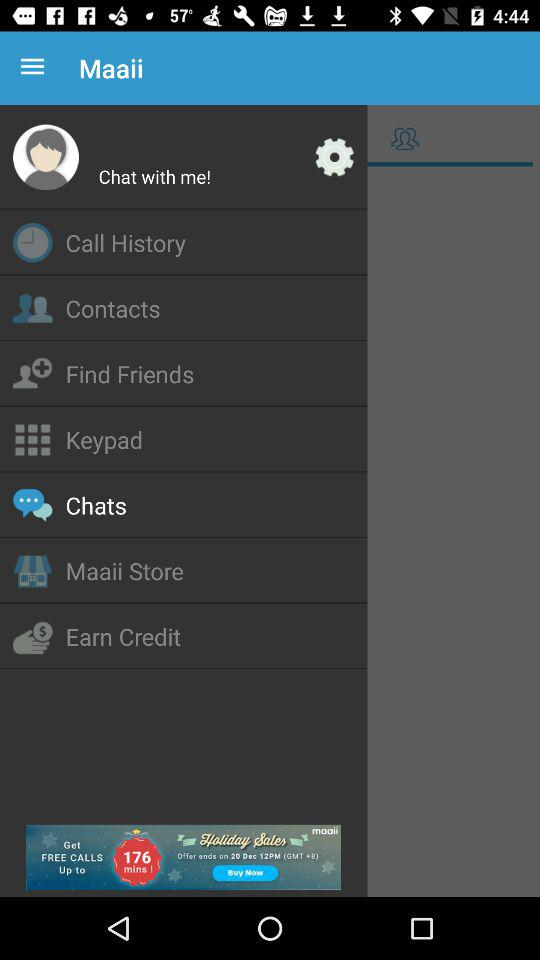Which item is selected? The selected item is "Chats". 